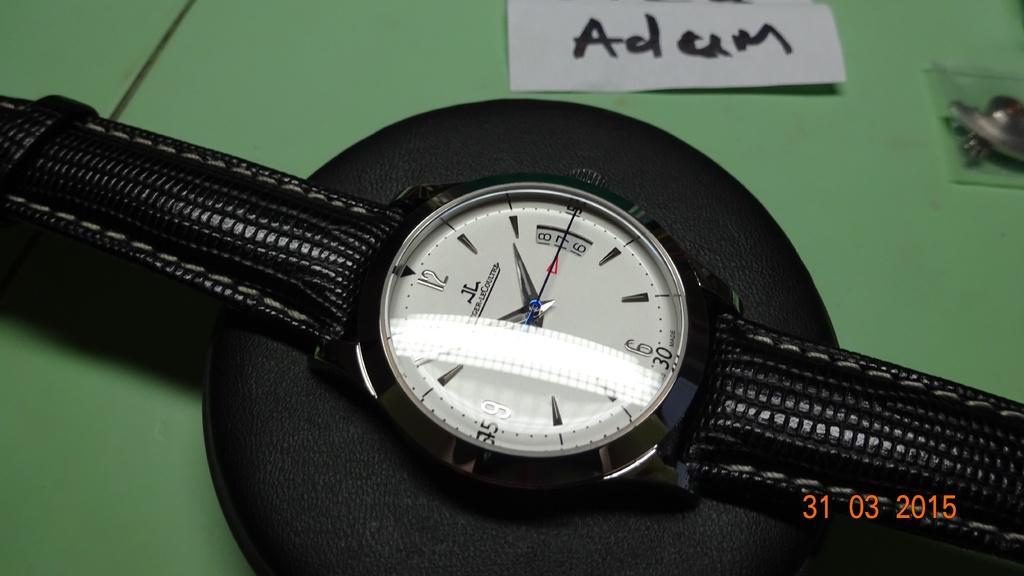In one or two sentences, can you explain what this image depicts? In this image we can see watch placed on the table. 